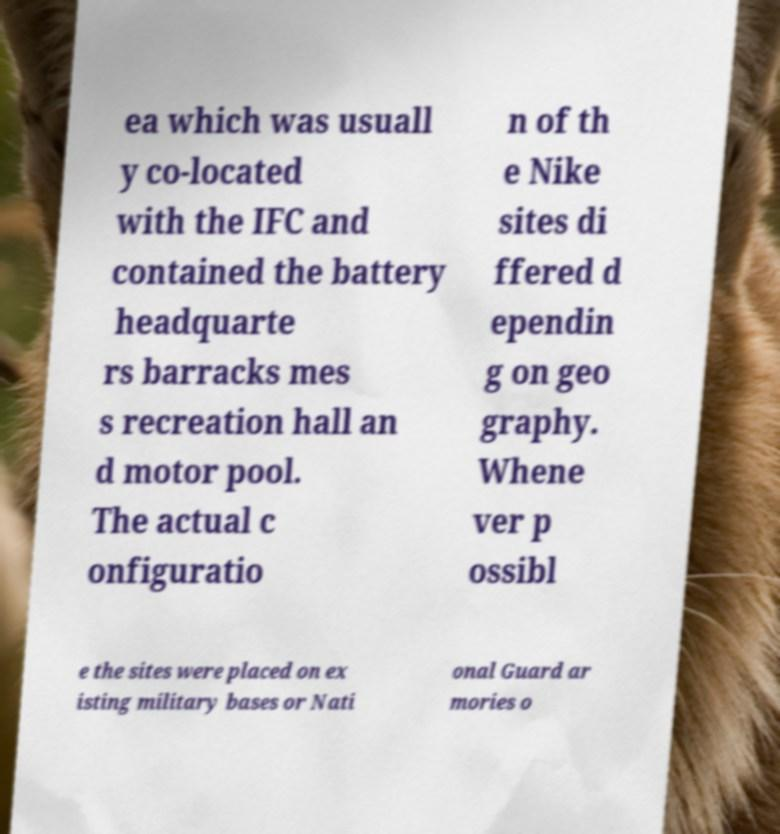Please read and relay the text visible in this image. What does it say? ea which was usuall y co-located with the IFC and contained the battery headquarte rs barracks mes s recreation hall an d motor pool. The actual c onfiguratio n of th e Nike sites di ffered d ependin g on geo graphy. Whene ver p ossibl e the sites were placed on ex isting military bases or Nati onal Guard ar mories o 